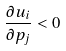<formula> <loc_0><loc_0><loc_500><loc_500>\frac { \partial u _ { i } } { \partial p _ { j } } < 0</formula> 